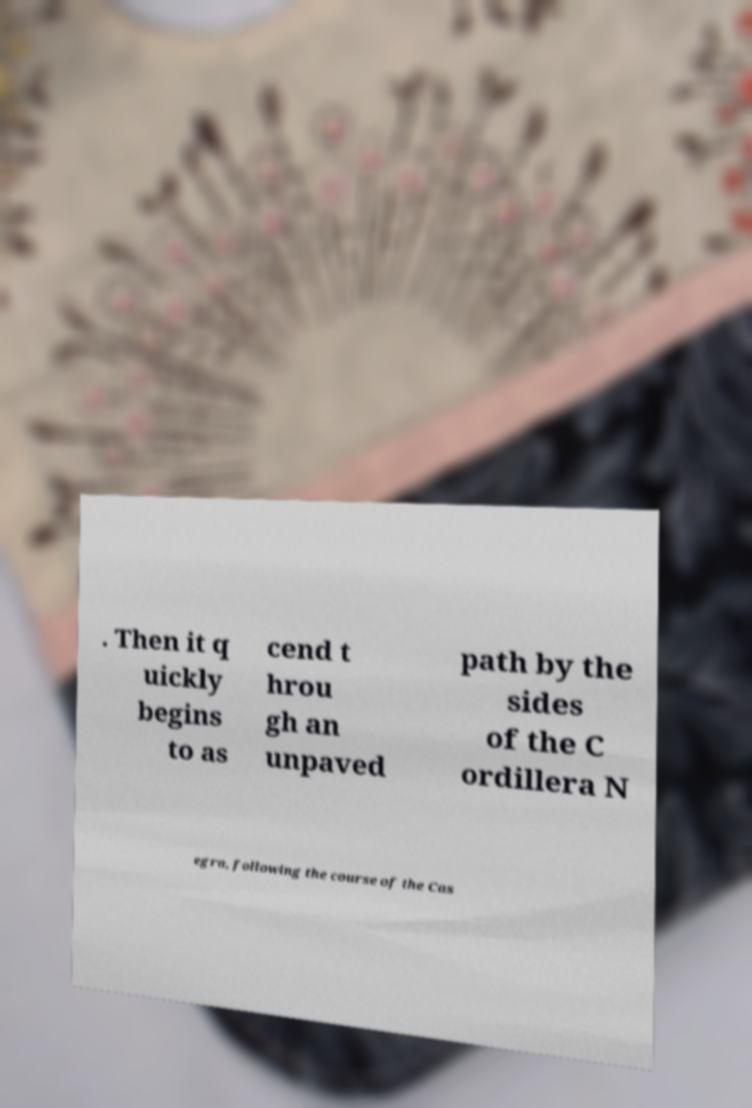Could you extract and type out the text from this image? . Then it q uickly begins to as cend t hrou gh an unpaved path by the sides of the C ordillera N egra, following the course of the Cas 